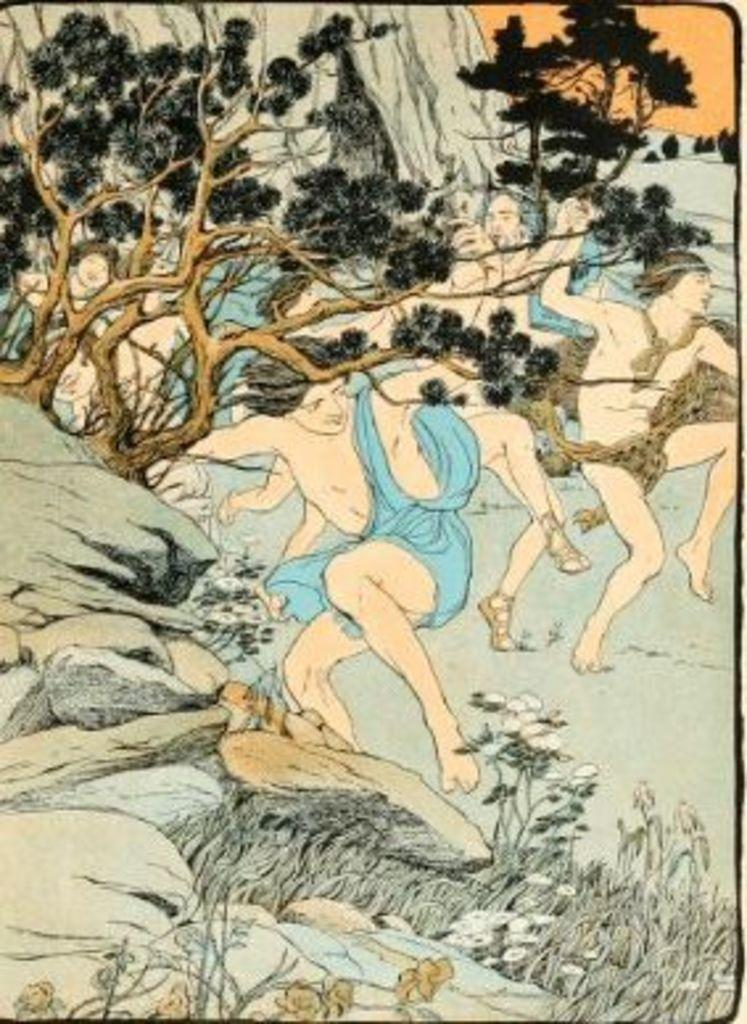How many people are in the image? There are persons in the image, but the exact number cannot be determined from the provided facts. What type of natural elements can be seen in the image? There are trees and stones in the image. What type of flowers are growing on the stones in the image? There are no flowers mentioned or visible in the image; only trees and stones are present. 